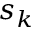Convert formula to latex. <formula><loc_0><loc_0><loc_500><loc_500>s _ { k }</formula> 